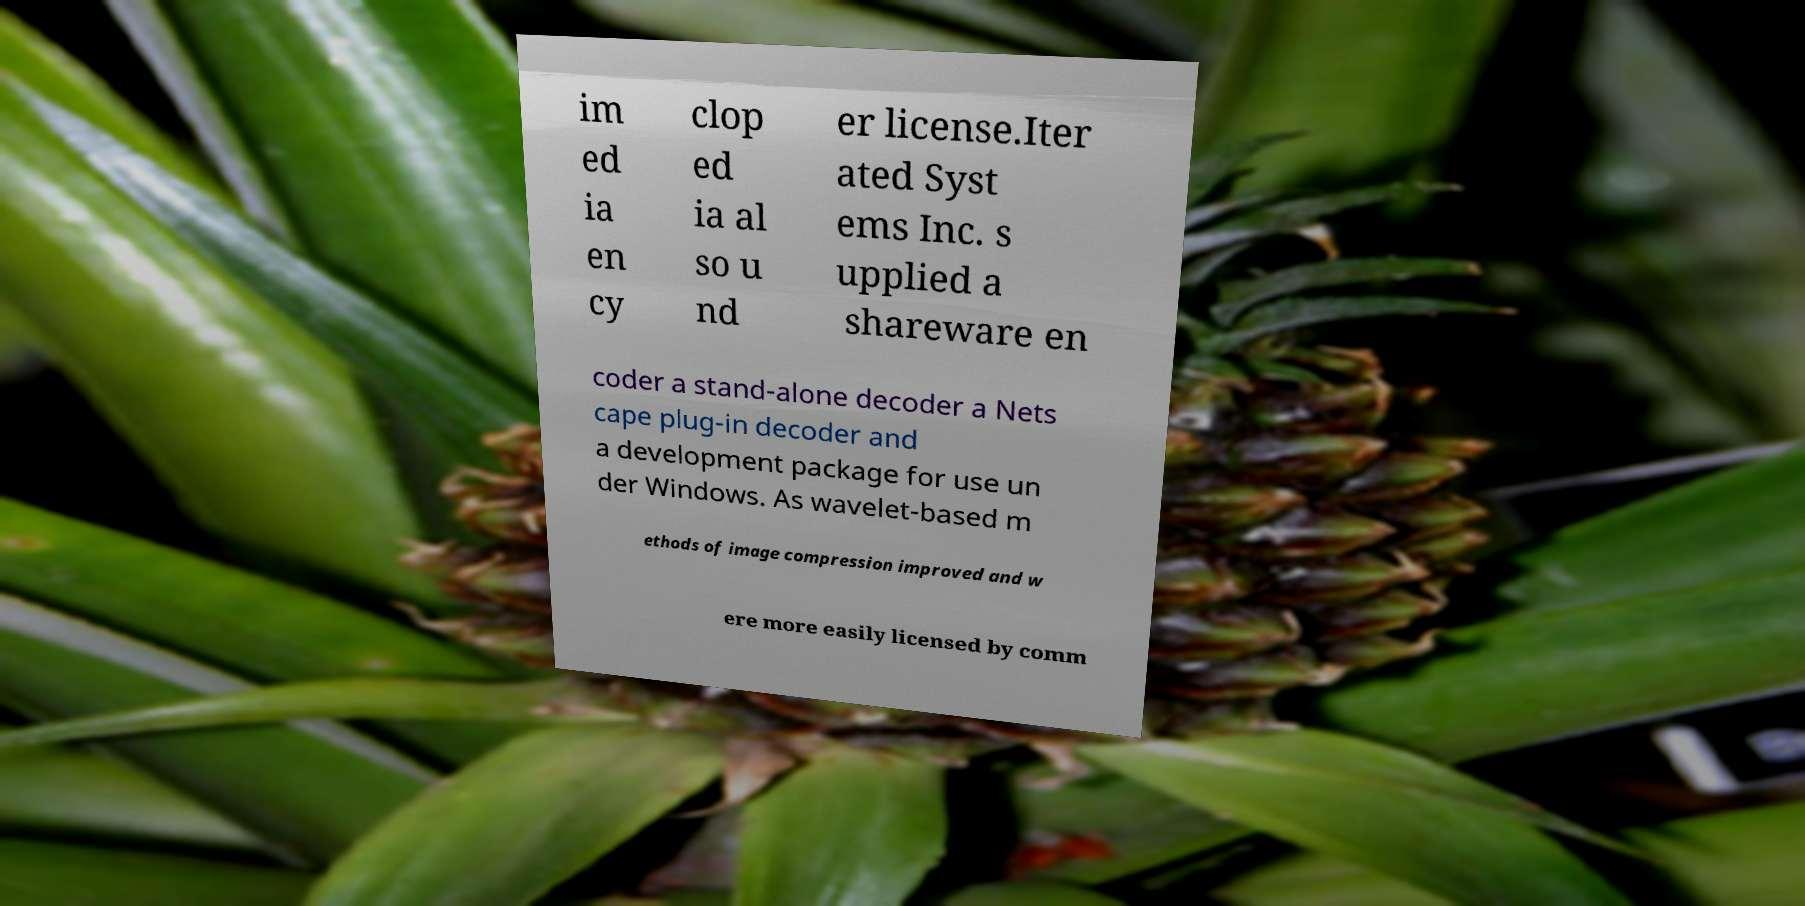For documentation purposes, I need the text within this image transcribed. Could you provide that? im ed ia en cy clop ed ia al so u nd er license.Iter ated Syst ems Inc. s upplied a shareware en coder a stand-alone decoder a Nets cape plug-in decoder and a development package for use un der Windows. As wavelet-based m ethods of image compression improved and w ere more easily licensed by comm 